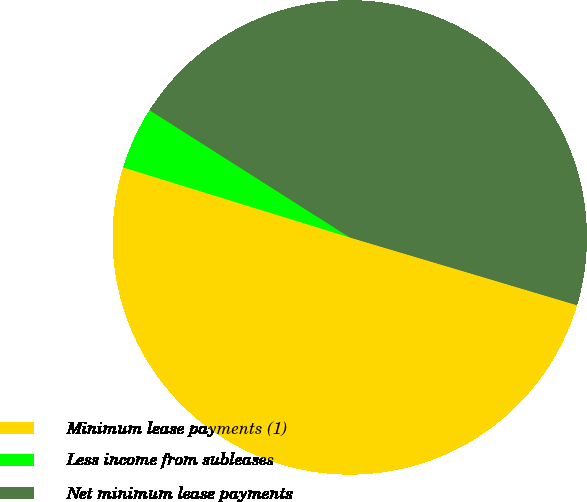<chart> <loc_0><loc_0><loc_500><loc_500><pie_chart><fcel>Minimum lease payments (1)<fcel>Less income from subleases<fcel>Net minimum lease payments<nl><fcel>50.16%<fcel>4.24%<fcel>45.6%<nl></chart> 